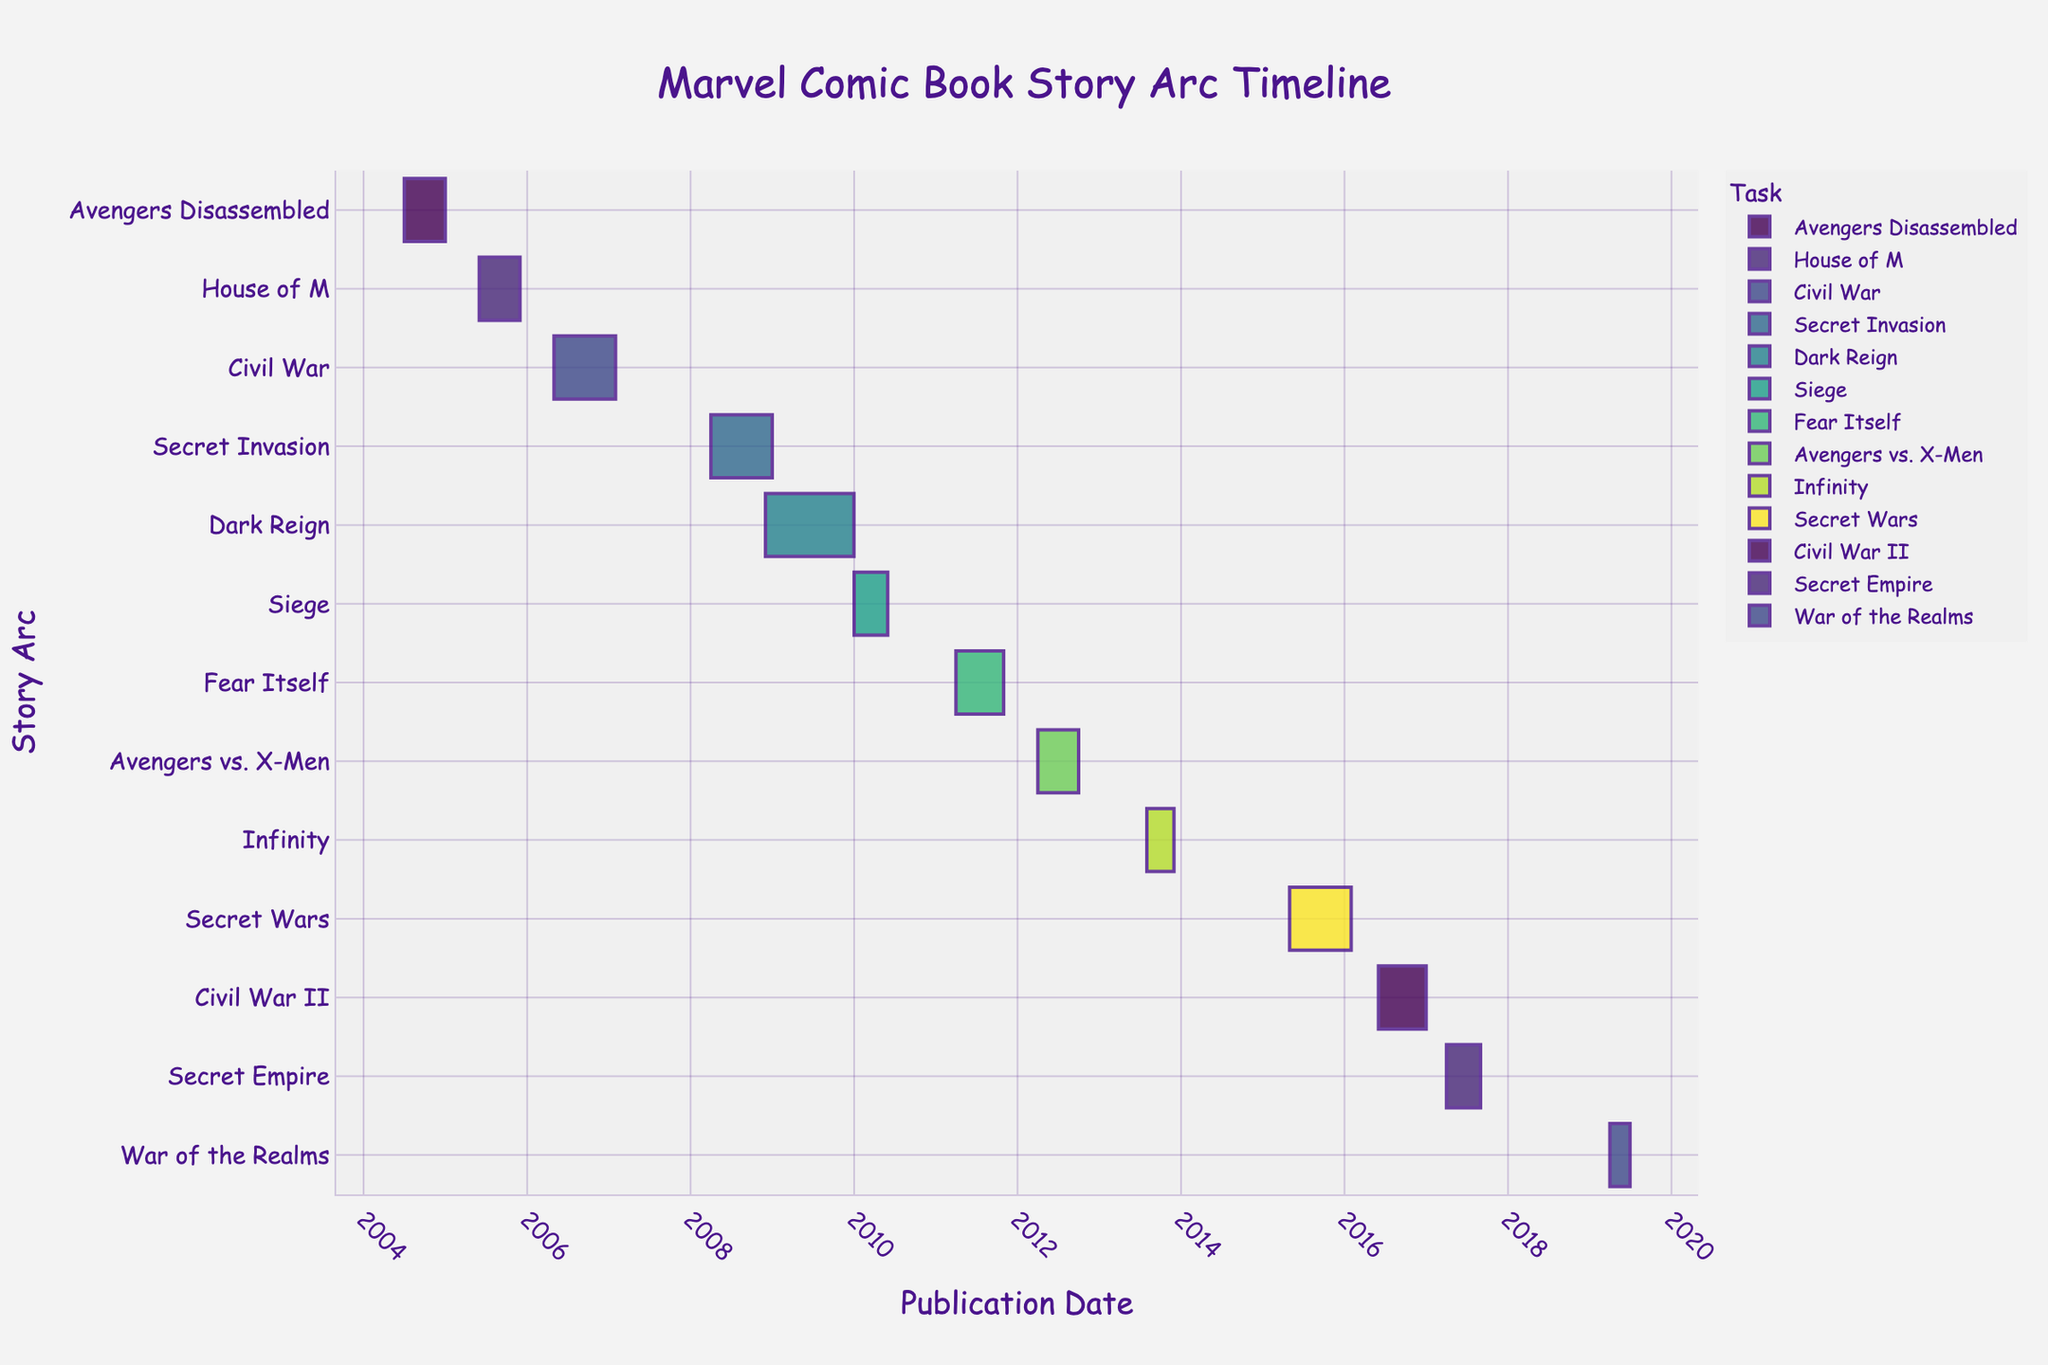What is the title of the Gantt Chart? The title is usually displayed prominently at the top of the chart and is meant to give a summary of the content. The title here is "Marvel Comic Book Story Arc Timeline," indicating that the chart shows the timelines for different Marvel story arcs.
Answer: Marvel Comic Book Story Arc Timeline What is the earliest story arc, and when did it start? To find the earliest story arc, look for the task bar that starts at the earliest date on the x-axis. The earliest story arc is "Avengers Disassembled," which started on July 1, 2004.
Answer: Avengers Disassembled, 2004-07-01 Which story arc has the longest duration, and how long is it? To find the longest duration, measure the length of each bar on the timeline. "Dark Reign" has the longest duration from December 1, 2008, to December 31, 2009, lasting 396 days.
Answer: Dark Reign, 396 days How many story arcs were published between 2005 and 2010 inclusive? Look for bars whose start and/or end dates fall within the specified range. The story arcs are "House of M," "Civil War," "Secret Invasion," "Dark Reign," and "Siege." This includes 5 story arcs.
Answer: 5 Did any story arc end in the same month another one started? Look for overlapping dates between the end of one task and the start of the next. "Secret Invasion" ended in December 2008 while "Dark Reign" started in the same month, December 2008.
Answer: Yes Which story arcs overlap in their timelines? Identify tasks whose bars on the chart overlap each other. "Secret Invasion" and "Dark Reign" (April 2008 – Dec 2008 overlaps with Dec 2008 – Dec 2009), and "Civil War" and "Secret Invasion" (May 2006 – Jan 2007 overlaps with April 2008 – Dec 2008) are examples of overlapping story arcs.
Answer: Secret Invasion and Dark Reign, Civil War and Secret Invasion Which year had the highest number of ongoing story arcs? Count the number of tasks that include dates within each year. The year 2011 had the highest number with "Fear Itself" ongoing from April to October, and 2012 did too with "Avengers vs. X-Men" from April to September.
Answer: 2011 and 2012 What is the average duration of the story arcs? Calculate the duration for each story arc, sum them up, and divide by the number of story arcs. Total duration in days of all arcs divided by the number of arcs (13). For example, total() = (6+6+9+9+12+5+7+6+4+9+7) = 85 / 13 = ~7 months.
Answer: ~7 months Which story arc started immediately after "Fear Itself"? Look for the start date immediately following the end date of "Fear Itself," which ended in October 2011. "Avengers vs. X-Men," which started in April 2012, is the next after "Fear Itself."
Answer: Avengers vs. X-Men 